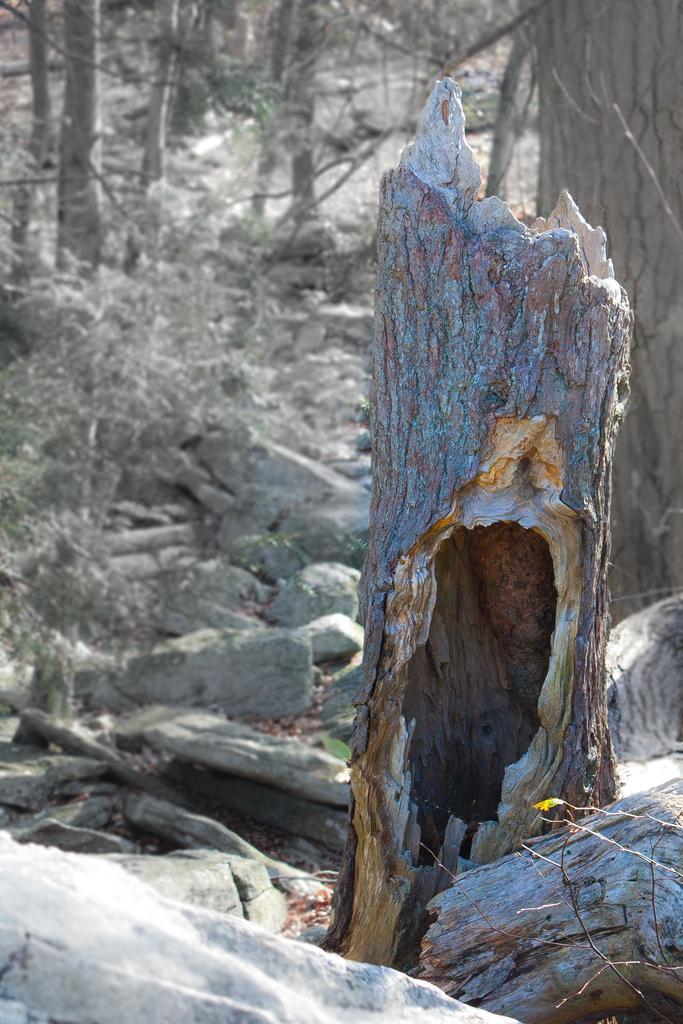Could you give a brief overview of what you see in this image? In this image, there is an outside view. There is a log in the middle of the image. In the background of the image, there are some trees. 